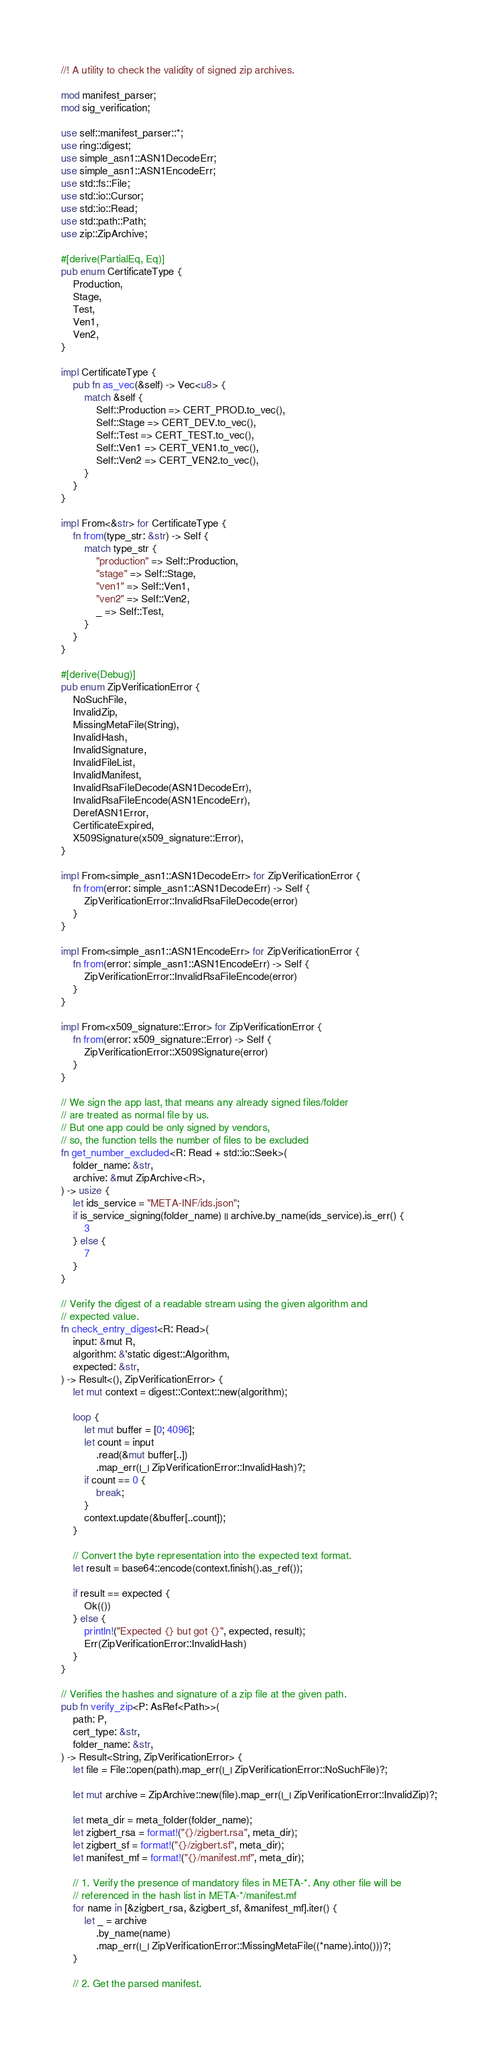Convert code to text. <code><loc_0><loc_0><loc_500><loc_500><_Rust_>//! A utility to check the validity of signed zip archives.

mod manifest_parser;
mod sig_verification;

use self::manifest_parser::*;
use ring::digest;
use simple_asn1::ASN1DecodeErr;
use simple_asn1::ASN1EncodeErr;
use std::fs::File;
use std::io::Cursor;
use std::io::Read;
use std::path::Path;
use zip::ZipArchive;

#[derive(PartialEq, Eq)]
pub enum CertificateType {
    Production,
    Stage,
    Test,
    Ven1,
    Ven2,
}

impl CertificateType {
    pub fn as_vec(&self) -> Vec<u8> {
        match &self {
            Self::Production => CERT_PROD.to_vec(),
            Self::Stage => CERT_DEV.to_vec(),
            Self::Test => CERT_TEST.to_vec(),
            Self::Ven1 => CERT_VEN1.to_vec(),
            Self::Ven2 => CERT_VEN2.to_vec(),
        }
    }
}

impl From<&str> for CertificateType {
    fn from(type_str: &str) -> Self {
        match type_str {
            "production" => Self::Production,
            "stage" => Self::Stage,
            "ven1" => Self::Ven1,
            "ven2" => Self::Ven2,
            _ => Self::Test,
        }
    }
}

#[derive(Debug)]
pub enum ZipVerificationError {
    NoSuchFile,
    InvalidZip,
    MissingMetaFile(String),
    InvalidHash,
    InvalidSignature,
    InvalidFileList,
    InvalidManifest,
    InvalidRsaFileDecode(ASN1DecodeErr),
    InvalidRsaFileEncode(ASN1EncodeErr),
    DerefASN1Error,
    CertificateExpired,
    X509Signature(x509_signature::Error),
}

impl From<simple_asn1::ASN1DecodeErr> for ZipVerificationError {
    fn from(error: simple_asn1::ASN1DecodeErr) -> Self {
        ZipVerificationError::InvalidRsaFileDecode(error)
    }
}

impl From<simple_asn1::ASN1EncodeErr> for ZipVerificationError {
    fn from(error: simple_asn1::ASN1EncodeErr) -> Self {
        ZipVerificationError::InvalidRsaFileEncode(error)
    }
}

impl From<x509_signature::Error> for ZipVerificationError {
    fn from(error: x509_signature::Error) -> Self {
        ZipVerificationError::X509Signature(error)
    }
}

// We sign the app last, that means any already signed files/folder
// are treated as normal file by us.
// But one app could be only signed by vendors,
// so, the function tells the number of files to be excluded
fn get_number_excluded<R: Read + std::io::Seek>(
    folder_name: &str,
    archive: &mut ZipArchive<R>,
) -> usize {
    let ids_service = "META-INF/ids.json";
    if is_service_signing(folder_name) || archive.by_name(ids_service).is_err() {
        3
    } else {
        7
    }
}

// Verify the digest of a readable stream using the given algorithm and
// expected value.
fn check_entry_digest<R: Read>(
    input: &mut R,
    algorithm: &'static digest::Algorithm,
    expected: &str,
) -> Result<(), ZipVerificationError> {
    let mut context = digest::Context::new(algorithm);

    loop {
        let mut buffer = [0; 4096];
        let count = input
            .read(&mut buffer[..])
            .map_err(|_| ZipVerificationError::InvalidHash)?;
        if count == 0 {
            break;
        }
        context.update(&buffer[..count]);
    }

    // Convert the byte representation into the expected text format.
    let result = base64::encode(context.finish().as_ref());

    if result == expected {
        Ok(())
    } else {
        println!("Expected {} but got {}", expected, result);
        Err(ZipVerificationError::InvalidHash)
    }
}

// Verifies the hashes and signature of a zip file at the given path.
pub fn verify_zip<P: AsRef<Path>>(
    path: P,
    cert_type: &str,
    folder_name: &str,
) -> Result<String, ZipVerificationError> {
    let file = File::open(path).map_err(|_| ZipVerificationError::NoSuchFile)?;

    let mut archive = ZipArchive::new(file).map_err(|_| ZipVerificationError::InvalidZip)?;

    let meta_dir = meta_folder(folder_name);
    let zigbert_rsa = format!("{}/zigbert.rsa", meta_dir);
    let zigbert_sf = format!("{}/zigbert.sf", meta_dir);
    let manifest_mf = format!("{}/manifest.mf", meta_dir);

    // 1. Verify the presence of mandatory files in META-*. Any other file will be
    // referenced in the hash list in META-*/manifest.mf
    for name in [&zigbert_rsa, &zigbert_sf, &manifest_mf].iter() {
        let _ = archive
            .by_name(name)
            .map_err(|_| ZipVerificationError::MissingMetaFile((*name).into()))?;
    }

    // 2. Get the parsed manifest.</code> 